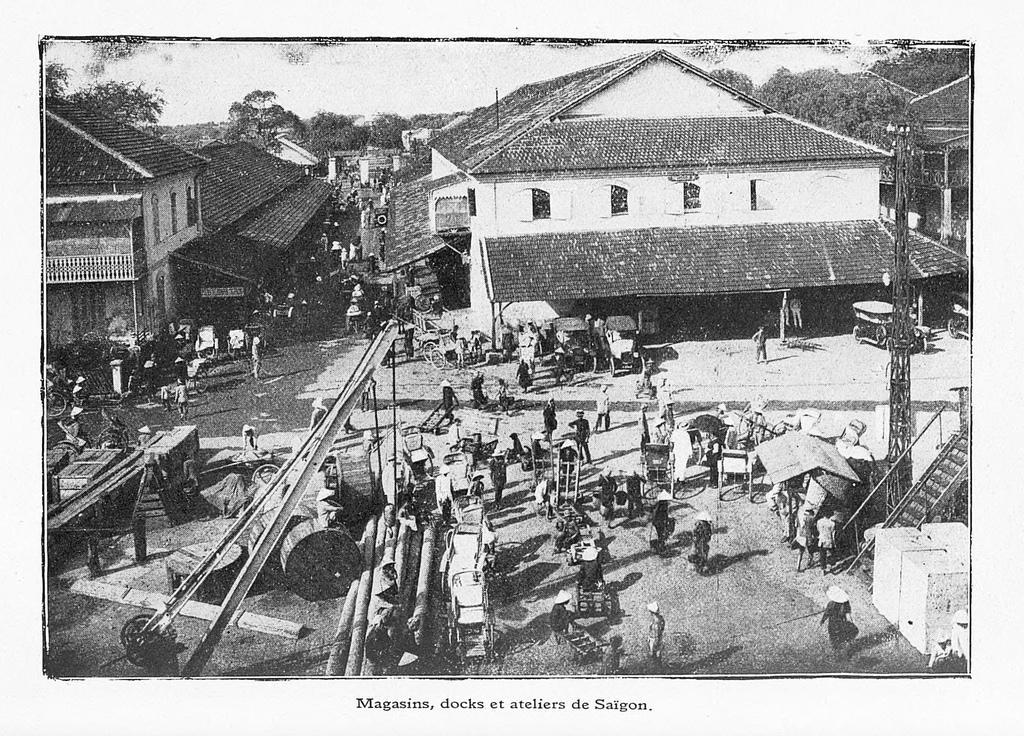How would you summarize this image in a sentence or two? This is an old black and white image. We can see people, vehicles, trees and the sky. On the right side of the image, there is a staircase and a truss. On the ground, there are wooden logs and some other objects. At the bottom of the image, it is written something. 